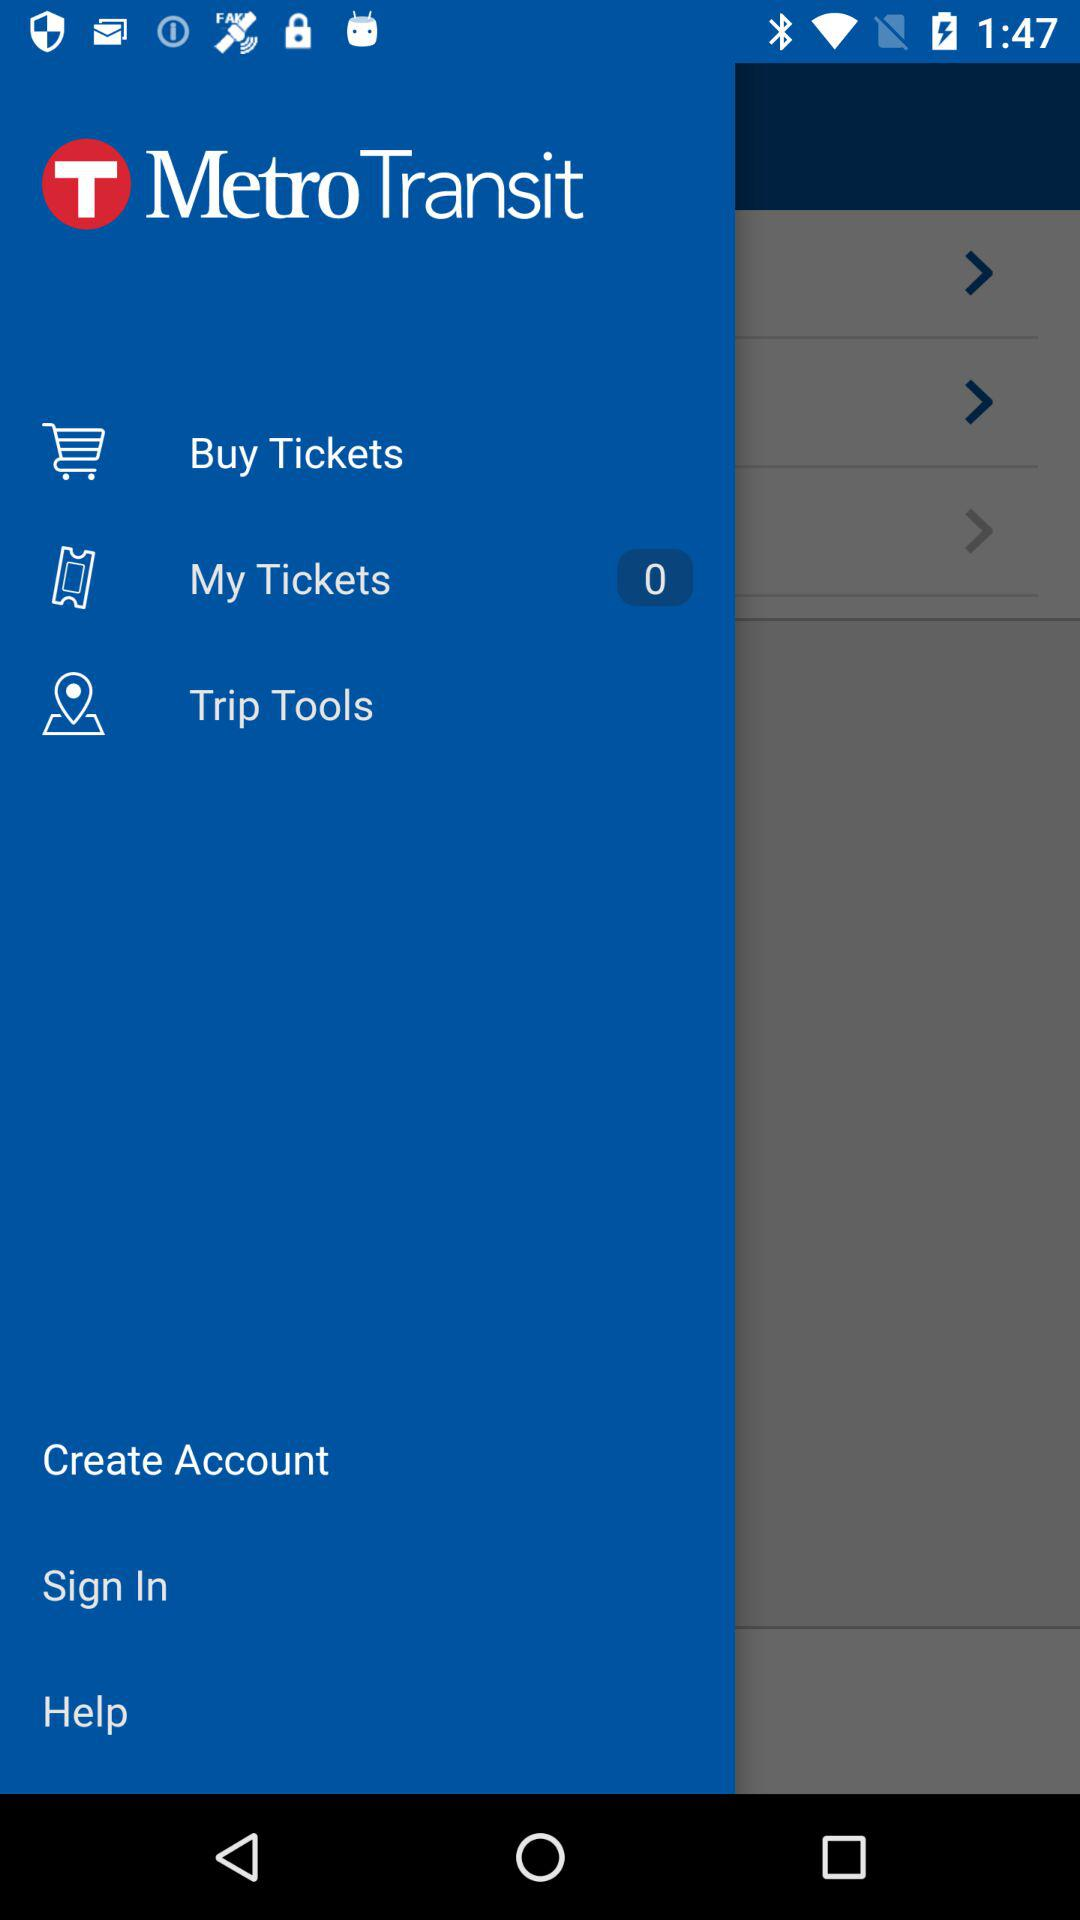What is the name of the application? The name of the application is "Metro Transit". 